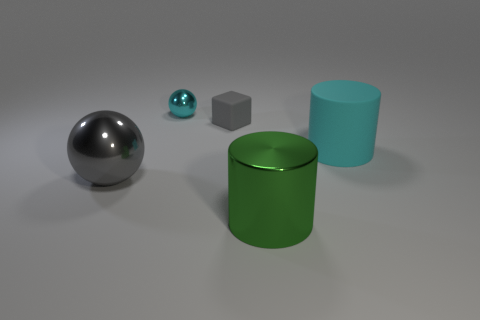Add 3 large gray things. How many objects exist? 8 Subtract all spheres. How many objects are left? 3 Subtract all gray balls. How many balls are left? 1 Subtract all gray cylinders. Subtract all cyan spheres. How many cylinders are left? 2 Add 2 large purple rubber cylinders. How many large purple rubber cylinders exist? 2 Subtract 0 blue cylinders. How many objects are left? 5 Subtract 1 spheres. How many spheres are left? 1 Subtract all tiny cyan cylinders. Subtract all matte blocks. How many objects are left? 4 Add 3 tiny gray matte blocks. How many tiny gray matte blocks are left? 4 